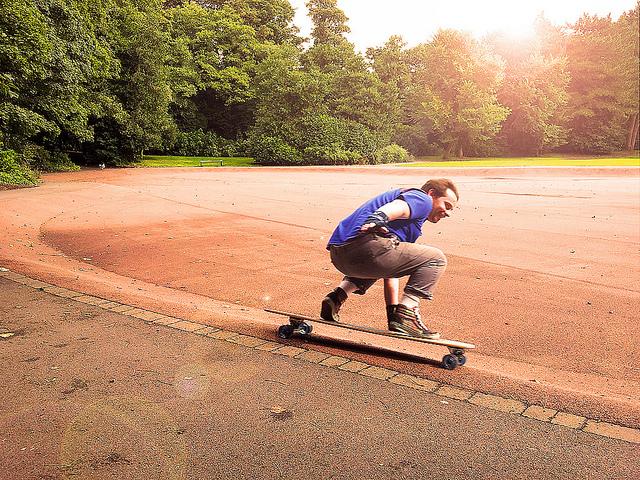Is the roadway straight or curved?
Write a very short answer. Curved. What is the man doing?
Short answer required. Skateboarding. Why does he wear gloves?
Short answer required. Safety. 